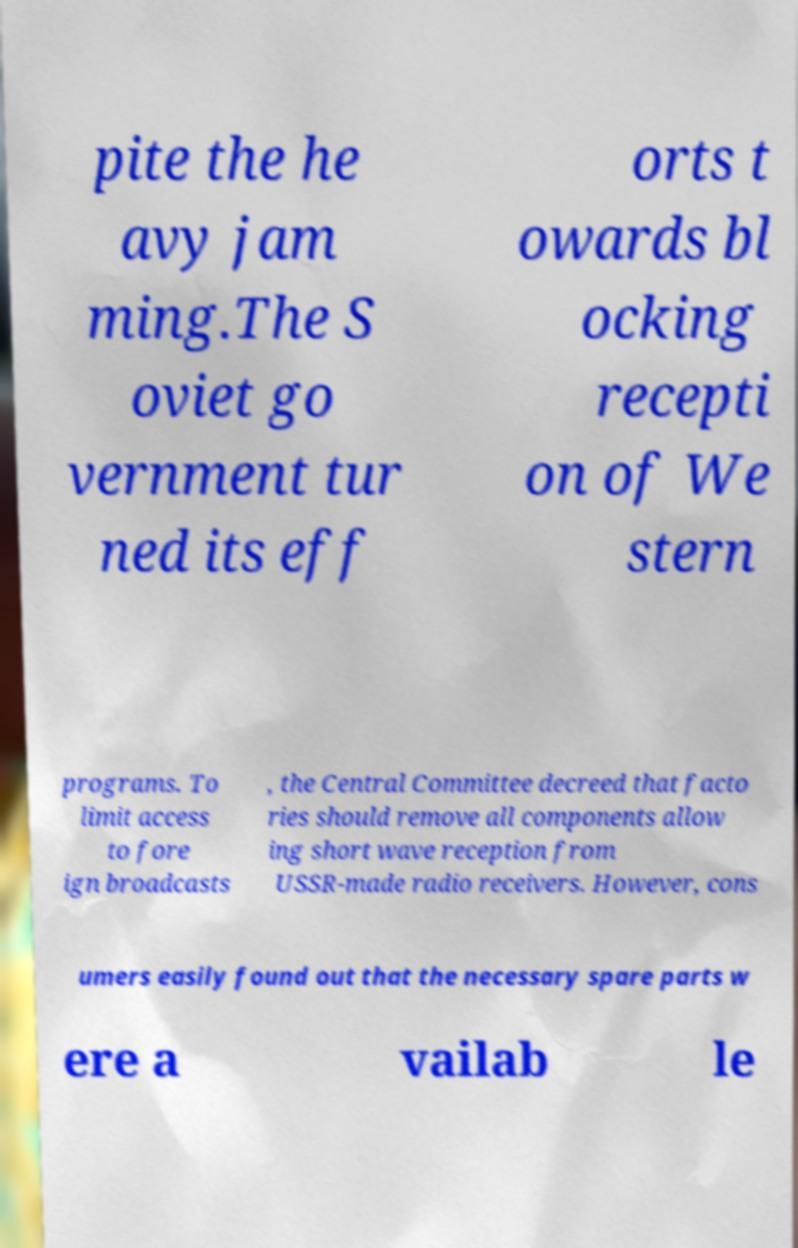Can you read and provide the text displayed in the image?This photo seems to have some interesting text. Can you extract and type it out for me? pite the he avy jam ming.The S oviet go vernment tur ned its eff orts t owards bl ocking recepti on of We stern programs. To limit access to fore ign broadcasts , the Central Committee decreed that facto ries should remove all components allow ing short wave reception from USSR-made radio receivers. However, cons umers easily found out that the necessary spare parts w ere a vailab le 